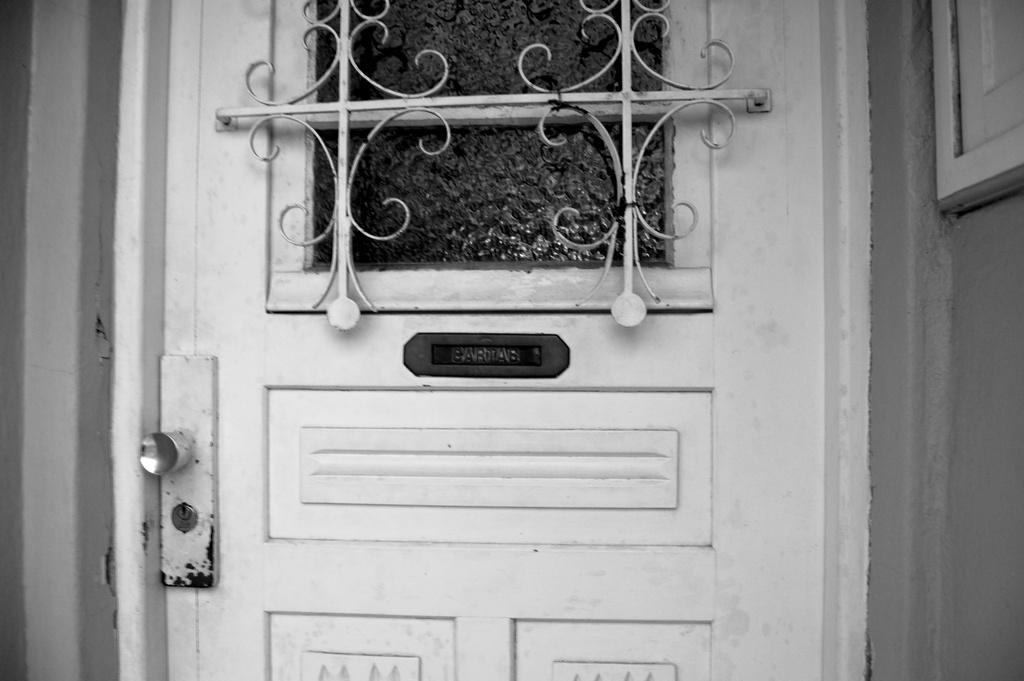What is the color scheme of the image? The image is black and white. What can be seen in the image that provides access to a room or space? There is a door in the image. What feature is present on the door that allows it to be opened or closed? The door has a door handle. What type of security or barrier is visible in the image? There appears to be an iron grill in the image. What material is used for the window attached to the door? There is a glass attached to the door. What type of structure is visible in the background of the image? There is a wall visible in the image. How does the building express its anger in the image? There is no building present in the image, and therefore no such expression of anger can be observed. What scientific theory is being demonstrated in the image? There is no scientific theory being demonstrated in the image; it features a door with a door handle, an iron grill, and a glass attached to it. 